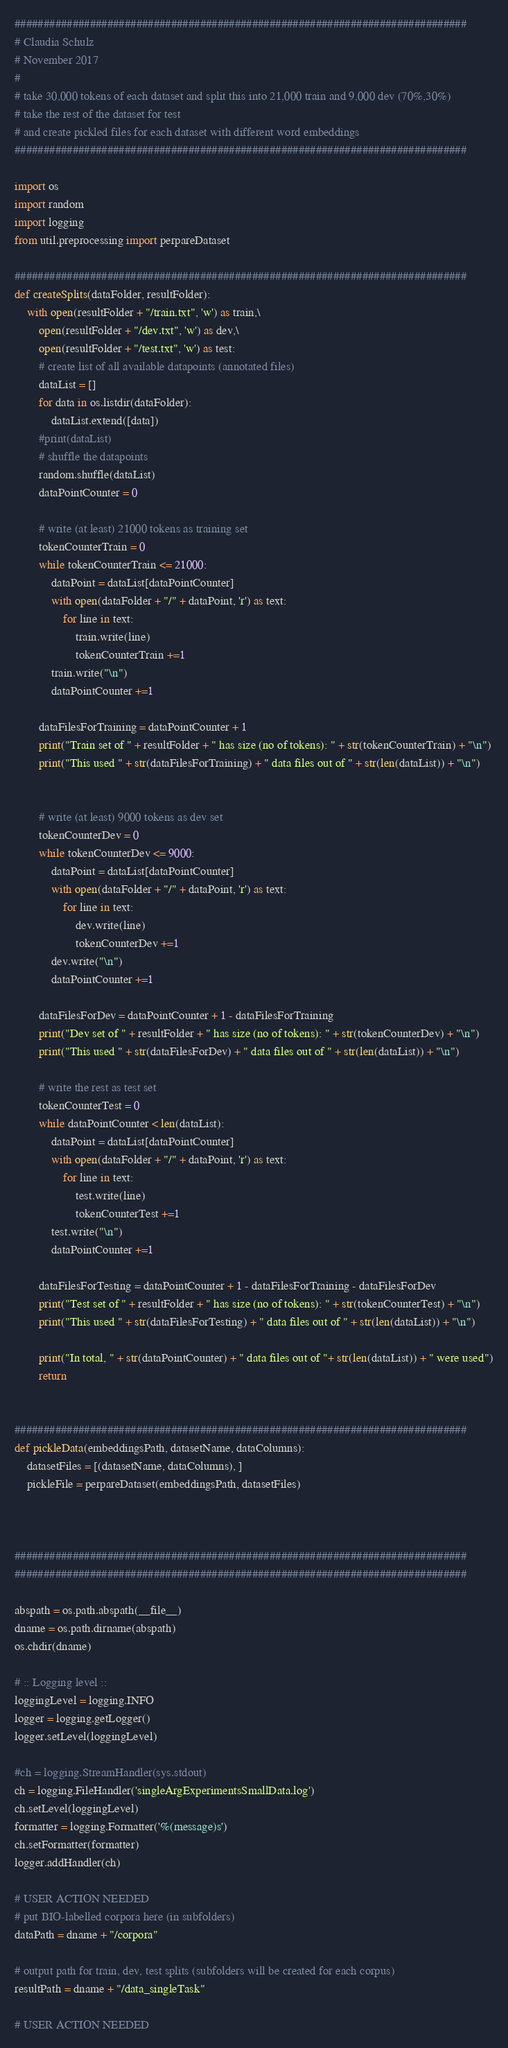<code> <loc_0><loc_0><loc_500><loc_500><_Python_>##############################################################################
# Claudia Schulz
# November 2017
#
# take 30,000 tokens of each dataset and split this into 21,000 train and 9,000 dev (70%,30%)
# take the rest of the dataset for test
# and create pickled files for each dataset with different word embeddings
##############################################################################

import os
import random
import logging
from util.preprocessing import perpareDataset

##############################################################################
def createSplits(dataFolder, resultFolder):
    with open(resultFolder + "/train.txt", 'w') as train,\
        open(resultFolder + "/dev.txt", 'w') as dev,\
        open(resultFolder + "/test.txt", 'w') as test:
        # create list of all available datapoints (annotated files)
        dataList = []
        for data in os.listdir(dataFolder):
            dataList.extend([data])
        #print(dataList)
        # shuffle the datapoints
        random.shuffle(dataList)
        dataPointCounter = 0

        # write (at least) 21000 tokens as training set
        tokenCounterTrain = 0
        while tokenCounterTrain <= 21000:
            dataPoint = dataList[dataPointCounter]
            with open(dataFolder + "/" + dataPoint, 'r') as text:
                for line in text:
                    train.write(line)
                    tokenCounterTrain +=1
            train.write("\n")
            dataPointCounter +=1

        dataFilesForTraining = dataPointCounter + 1
        print("Train set of " + resultFolder + " has size (no of tokens): " + str(tokenCounterTrain) + "\n")
        print("This used " + str(dataFilesForTraining) + " data files out of " + str(len(dataList)) + "\n")


        # write (at least) 9000 tokens as dev set
        tokenCounterDev = 0
        while tokenCounterDev <= 9000:
            dataPoint = dataList[dataPointCounter]
            with open(dataFolder + "/" + dataPoint, 'r') as text:
                for line in text:
                    dev.write(line)
                    tokenCounterDev +=1
            dev.write("\n")
            dataPointCounter +=1

        dataFilesForDev = dataPointCounter + 1 - dataFilesForTraining
        print("Dev set of " + resultFolder + " has size (no of tokens): " + str(tokenCounterDev) + "\n")
        print("This used " + str(dataFilesForDev) + " data files out of " + str(len(dataList)) + "\n")

        # write the rest as test set
        tokenCounterTest = 0
        while dataPointCounter < len(dataList):
            dataPoint = dataList[dataPointCounter]
            with open(dataFolder + "/" + dataPoint, 'r') as text:
                for line in text:
                    test.write(line)
                    tokenCounterTest +=1
            test.write("\n")
            dataPointCounter +=1

        dataFilesForTesting = dataPointCounter + 1 - dataFilesForTraining - dataFilesForDev
        print("Test set of " + resultFolder + " has size (no of tokens): " + str(tokenCounterTest) + "\n")
        print("This used " + str(dataFilesForTesting) + " data files out of " + str(len(dataList)) + "\n")

        print("In total, " + str(dataPointCounter) + " data files out of "+ str(len(dataList)) + " were used")
        return


##############################################################################
def pickleData(embeddingsPath, datasetName, dataColumns):
    datasetFiles = [(datasetName, dataColumns), ]
    pickleFile = perpareDataset(embeddingsPath, datasetFiles)



##############################################################################
##############################################################################

abspath = os.path.abspath(__file__)
dname = os.path.dirname(abspath)
os.chdir(dname)

# :: Logging level ::
loggingLevel = logging.INFO
logger = logging.getLogger()
logger.setLevel(loggingLevel)

#ch = logging.StreamHandler(sys.stdout)
ch = logging.FileHandler('singleArgExperimentsSmallData.log')
ch.setLevel(loggingLevel)
formatter = logging.Formatter('%(message)s')
ch.setFormatter(formatter)
logger.addHandler(ch)

# USER ACTION NEEDED
# put BIO-labelled corpora here (in subfolders)
dataPath = dname + "/corpora"

# output path for train, dev, test splits (subfolders will be created for each corpus)
resultPath = dname + "/data_singleTask"

# USER ACTION NEEDED</code> 